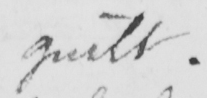Can you tell me what this handwritten text says? guilt 